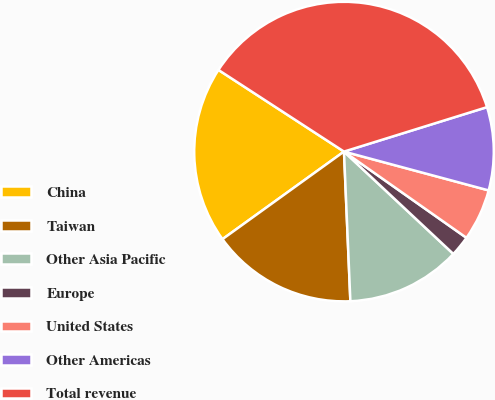<chart> <loc_0><loc_0><loc_500><loc_500><pie_chart><fcel>China<fcel>Taiwan<fcel>Other Asia Pacific<fcel>Europe<fcel>United States<fcel>Other Americas<fcel>Total revenue<nl><fcel>19.12%<fcel>15.74%<fcel>12.35%<fcel>2.21%<fcel>5.59%<fcel>8.97%<fcel>36.03%<nl></chart> 